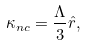<formula> <loc_0><loc_0><loc_500><loc_500>\kappa _ { n c } = \frac { \Lambda } { 3 } \hat { r } ,</formula> 